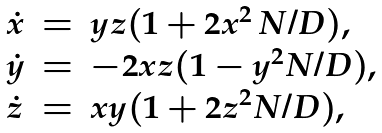Convert formula to latex. <formula><loc_0><loc_0><loc_500><loc_500>\begin{array} { l l l } \dot { x } & = & y z ( 1 + 2 x ^ { 2 } \, N / D ) , \\ \dot { y } & = & - 2 x z ( 1 - y ^ { 2 } N / D ) , \\ \dot { z } & = & x y ( 1 + 2 z ^ { 2 } N / D ) , \\ \end{array}</formula> 